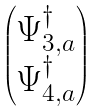Convert formula to latex. <formula><loc_0><loc_0><loc_500><loc_500>\begin{pmatrix} \Psi _ { 3 , a } ^ { \dagger } \\ \Psi _ { 4 , a } ^ { \dagger } \end{pmatrix}</formula> 